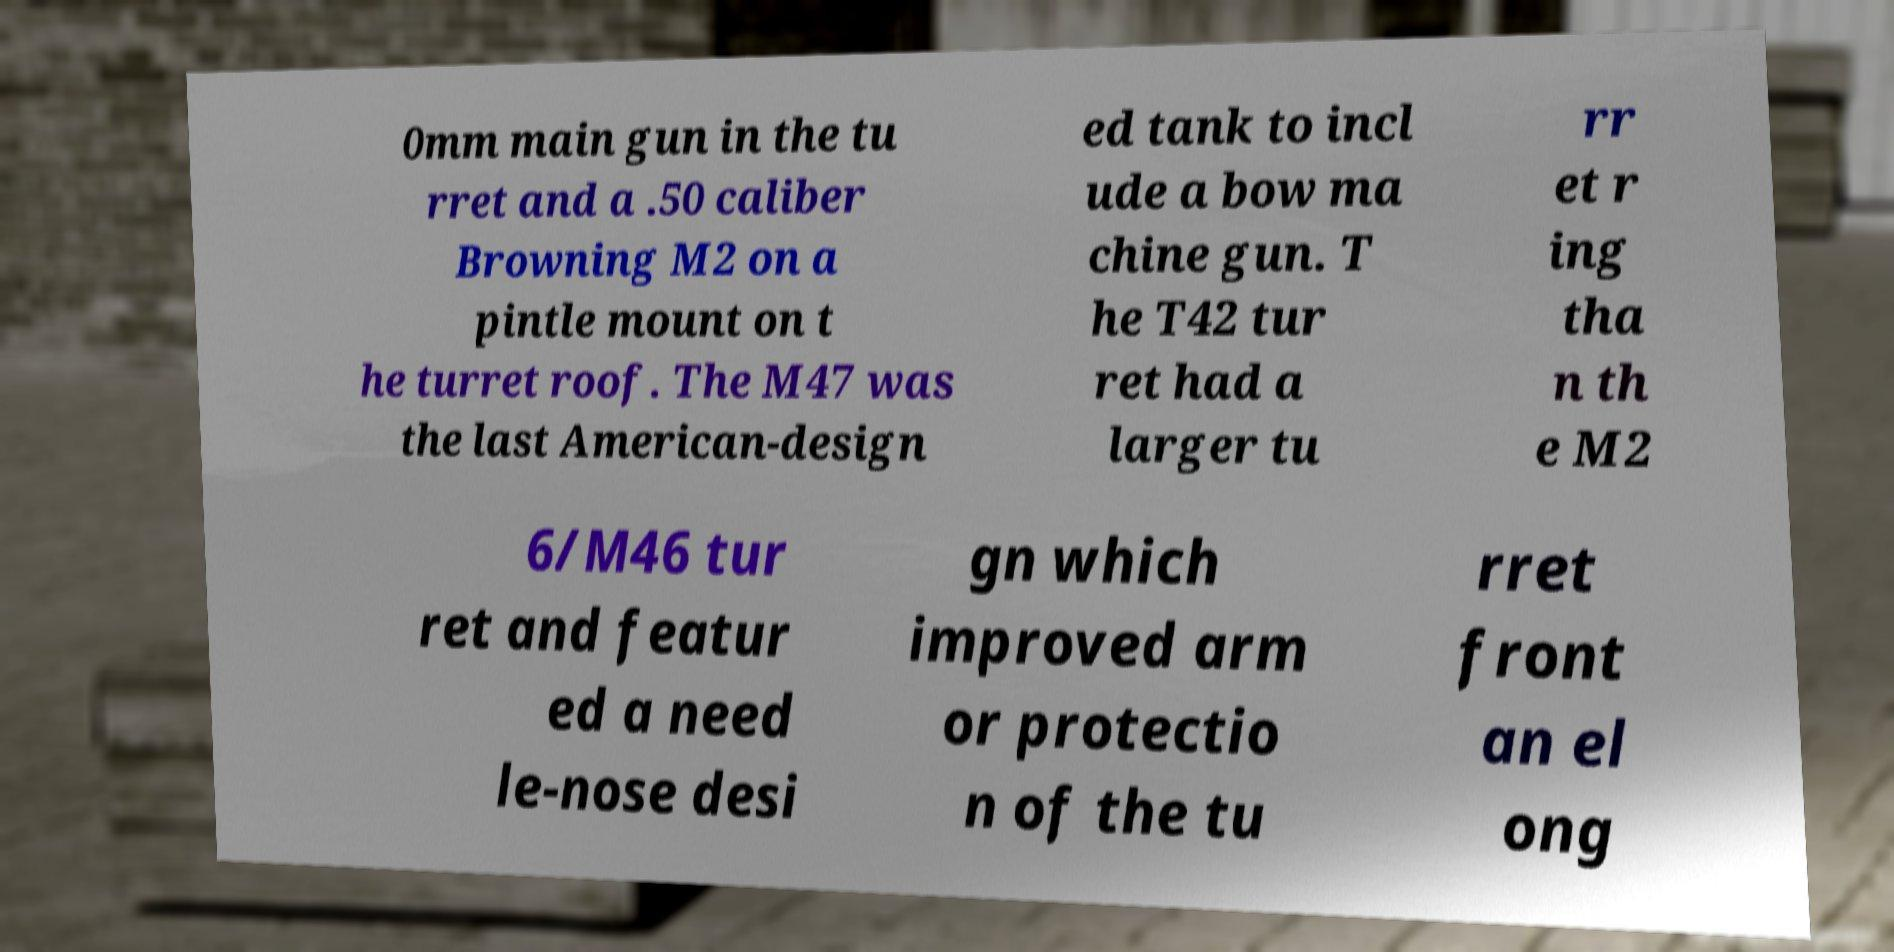Can you read and provide the text displayed in the image?This photo seems to have some interesting text. Can you extract and type it out for me? 0mm main gun in the tu rret and a .50 caliber Browning M2 on a pintle mount on t he turret roof. The M47 was the last American-design ed tank to incl ude a bow ma chine gun. T he T42 tur ret had a larger tu rr et r ing tha n th e M2 6/M46 tur ret and featur ed a need le-nose desi gn which improved arm or protectio n of the tu rret front an el ong 